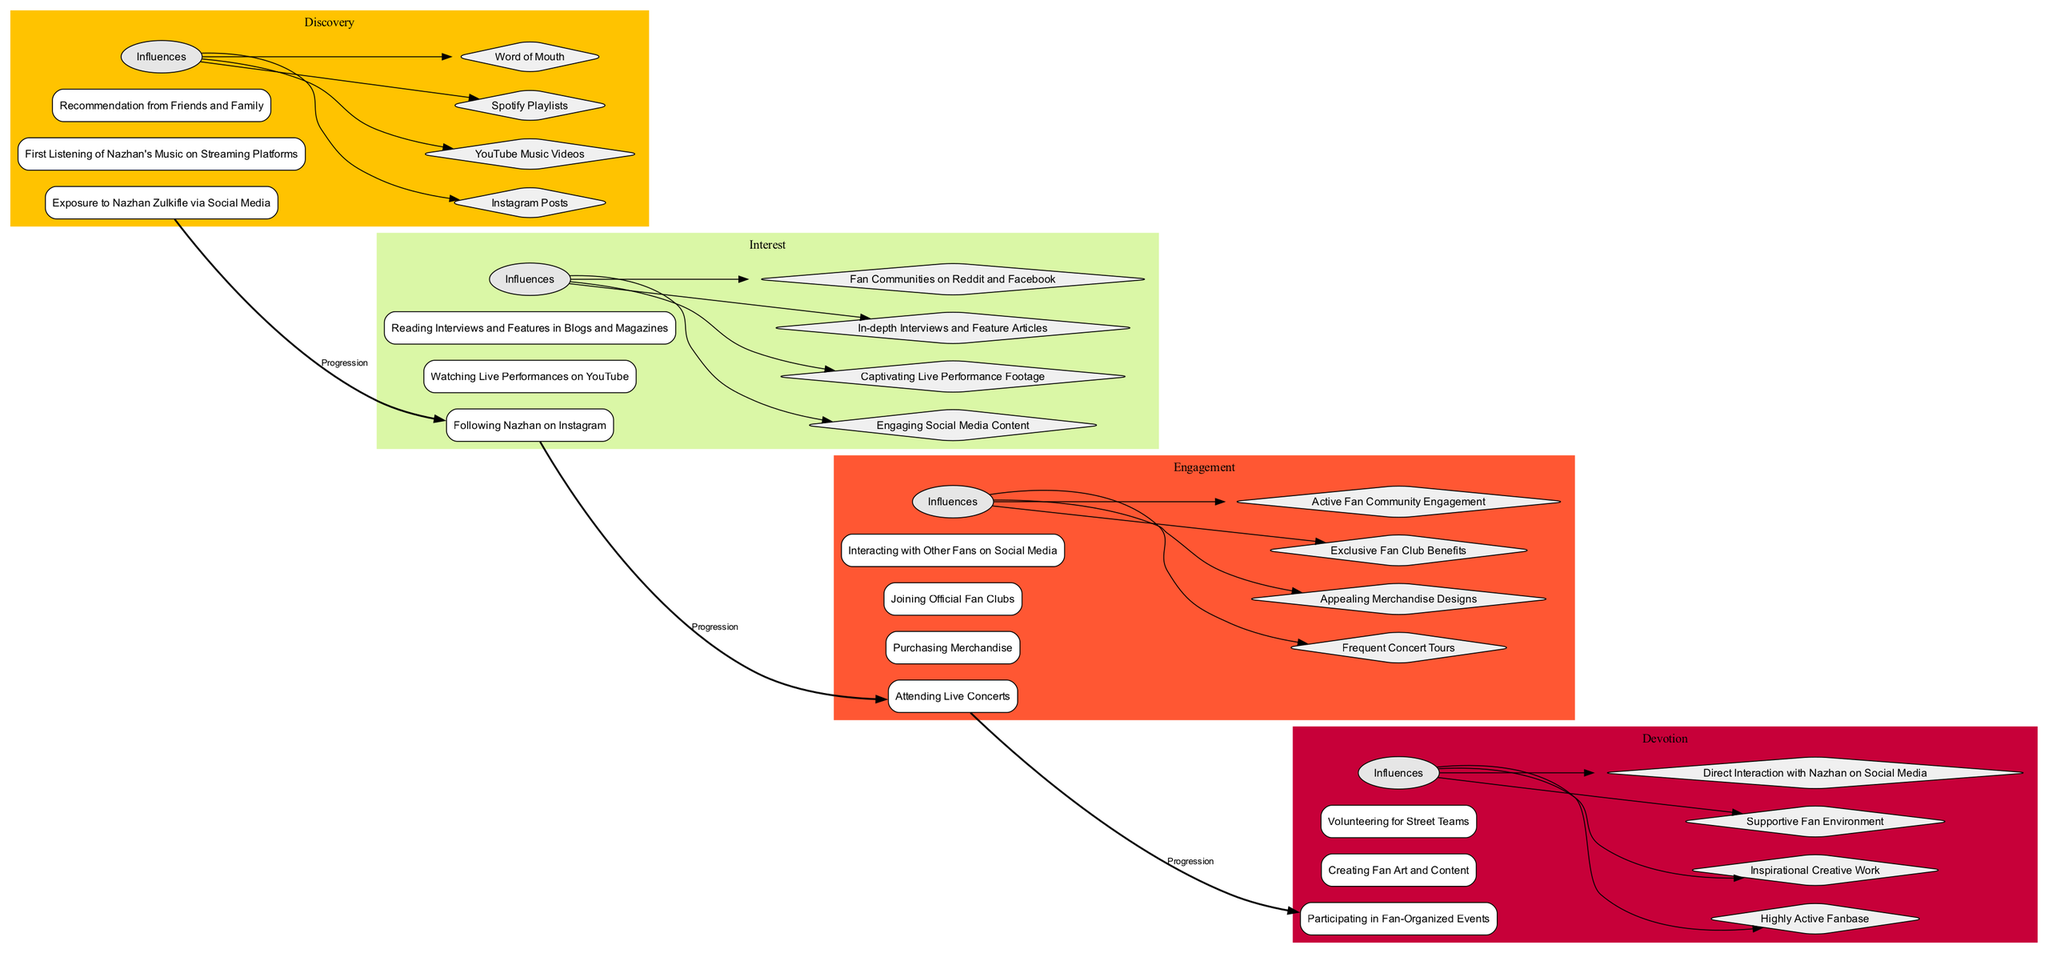What is the first milestone in the Discovery stage? The first milestone listed under the Discovery stage is "Exposure to Nazhan Zulkifle via Social Media." By checking the milestones for each stage in the diagram, we can directly identify this as the first listed item under Discovery.
Answer: Exposure to Nazhan Zulkifle via Social Media How many stages are depicted in the diagram? The diagram contains four stages: Discovery, Interest, Engagement, and Devotion. Counting each stage listed effectively reveals the total number of stages presented.
Answer: 4 What influences are associated with the Engagement stage? The influences related to the Engagement stage are: "Frequent Concert Tours," "Appealing Merchandise Designs," "Exclusive Fan Club Benefits," and "Active Fan Community Engagement." By reviewing the influences listed under Engagement, we find these four influences directly connected to this stage.
Answer: Frequent Concert Tours, Appealing Merchandise Designs, Exclusive Fan Club Benefits, Active Fan Community Engagement Which stage comes after Interest? The stage that follows Interest is Engagement. This can be verified by tracing the progression line in the diagram that connects Interest to the next sequential stage, Engagement.
Answer: Engagement What is the common theme among the milestones in the Devotion stage? The common theme among the milestones in the Devotion stage revolves around active participation and creativity, as seen in "Participating in Fan-Organized Events," "Creating Fan Art and Content," and "Volunteering for Street Teams." All milestones suggest deeper involvement in the fan community.
Answer: Active participation and creativity How many influences are listed for the Interest stage? There are four influences listed for the Interest stage: "Engaging Social Media Content," "Captivating Live Performance Footage," "In-depth Interviews and Feature Articles," and "Fan Communities on Reddit and Facebook." Each influence can be counted directly from the Interest stage's influences section.
Answer: 4 What is the last milestone in the Engagement stage? The last milestone in the Engagement stage is "Interacting with Other Fans on Social Media." By examining the list of milestones for Engagement, this is the final item presented.
Answer: Interacting with Other Fans on Social Media Which influence connects Devotion back to previous stages? The influence that connects Devotion back to previous stages is "Direct Interaction with Nazhan on Social Media." This influence suggests a relationship with earlier stages, especially Engagement, where social media interactions are also prominent.
Answer: Direct Interaction with Nazhan on Social Media What is the progression relationship between the Discovery and Interest stages? The relationship is characterized as "Progression," indicated by a directed edge that illustrates a move from the Discovery milestone to milestones in the Interest stage, signifying a transition from initially discovering Nazhan to developing a deeper interest.
Answer: Progression 